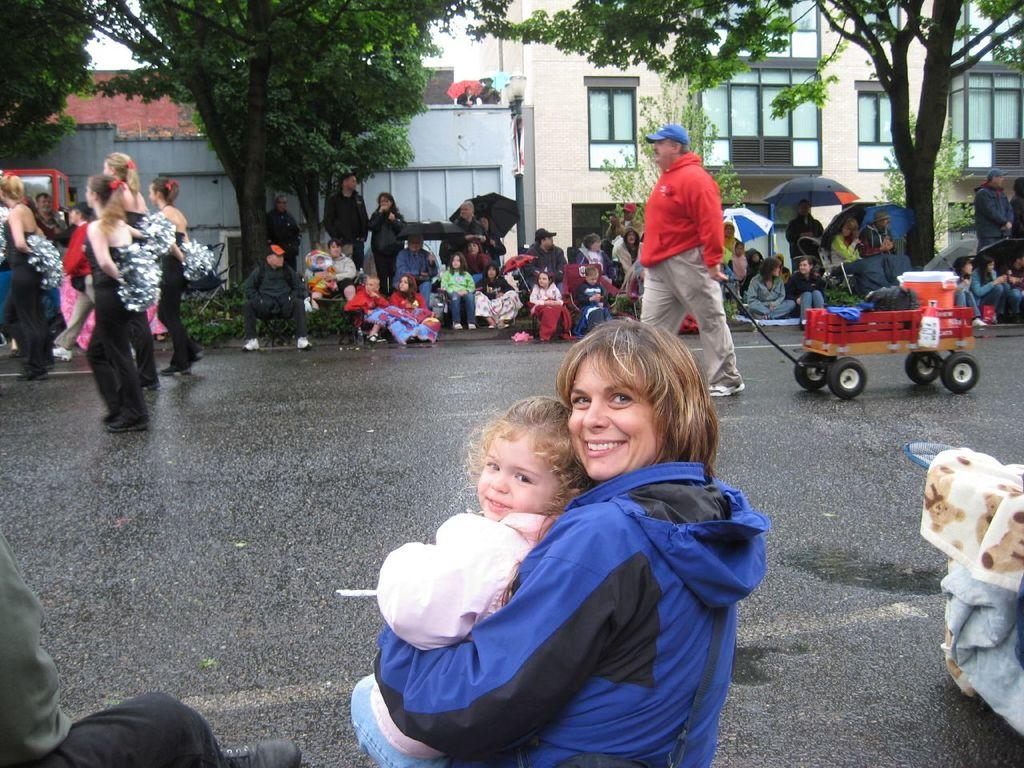What are the people in the image doing? People are sitting on either side of the road in the image. What is happening in the middle of the road? A man is walking with a small truck in the middle of the road. What can be seen in the background of the image? There are trees and houses in the background of the image. How many holes can be seen in the image? There are no holes visible in the image. What type of tools might a carpenter need in the image? There is no carpenter or tools present in the image. 